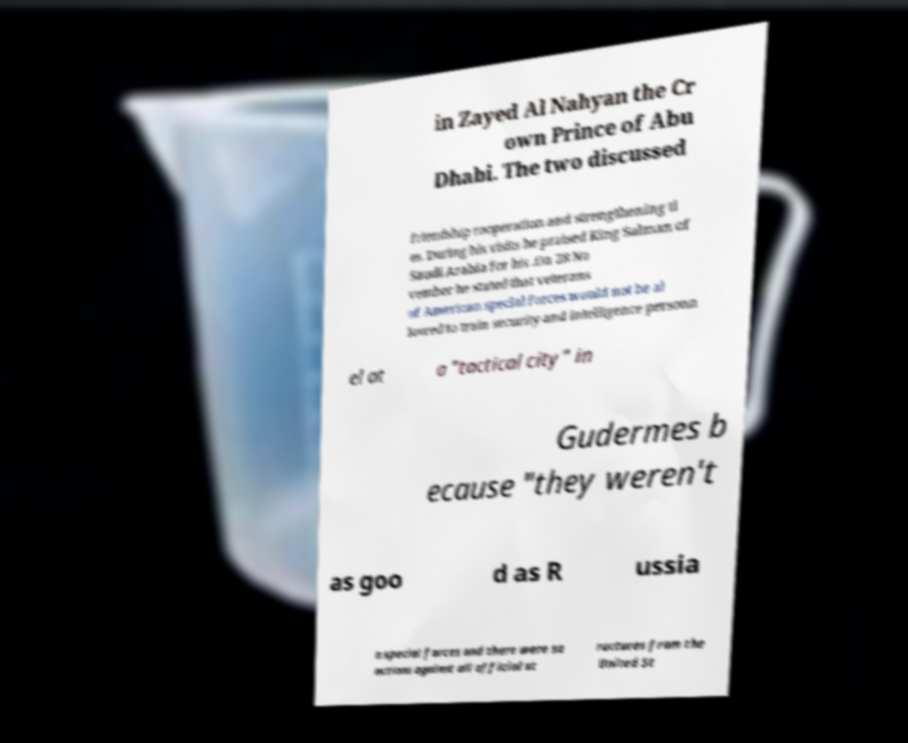Please read and relay the text visible in this image. What does it say? in Zayed Al Nahyan the Cr own Prince of Abu Dhabi. The two discussed friendship cooperation and strengthening ti es. During his visits he praised King Salman of Saudi Arabia for his .On 28 No vember he stated that veterans of American special forces would not be al lowed to train security and intelligence personn el at a "tactical city" in Gudermes b ecause "they weren't as goo d as R ussia n special forces and there were sa nctions against all official st ructures from the United St 